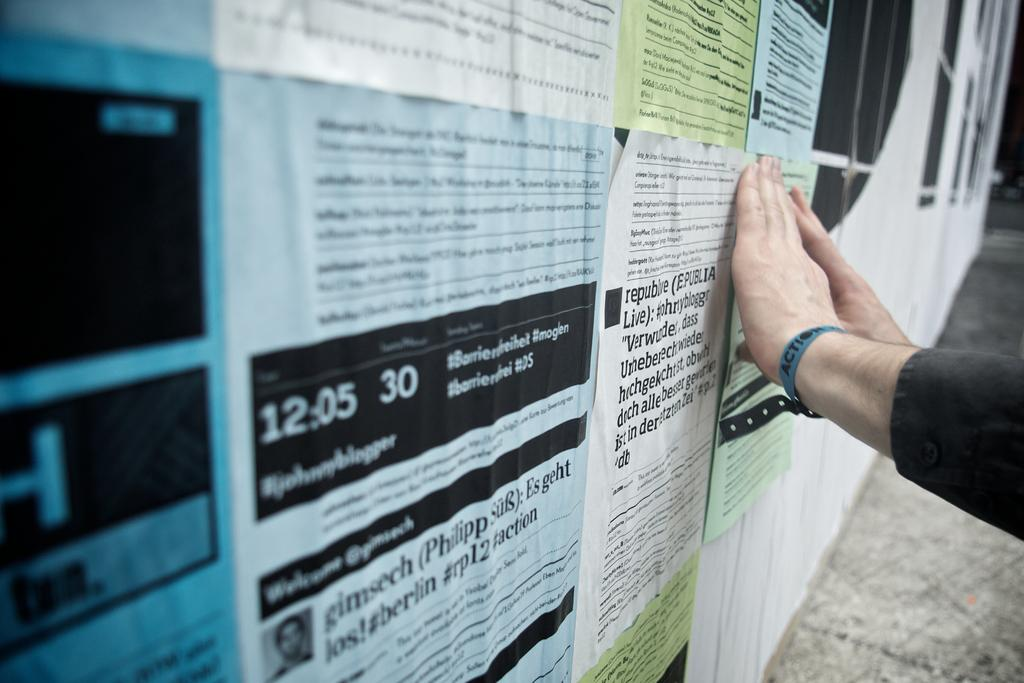Provide a one-sentence caption for the provided image. Bulletin board with flyers and one says the time of 12:05. 